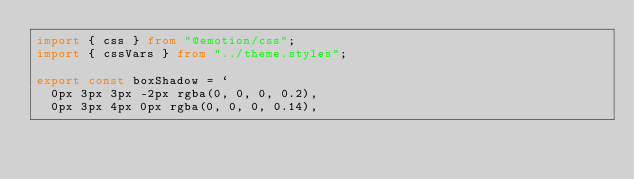Convert code to text. <code><loc_0><loc_0><loc_500><loc_500><_TypeScript_>import { css } from "@emotion/css";
import { cssVars } from "../theme.styles";

export const boxShadow = `
  0px 3px 3px -2px rgba(0, 0, 0, 0.2),
  0px 3px 4px 0px rgba(0, 0, 0, 0.14),</code> 